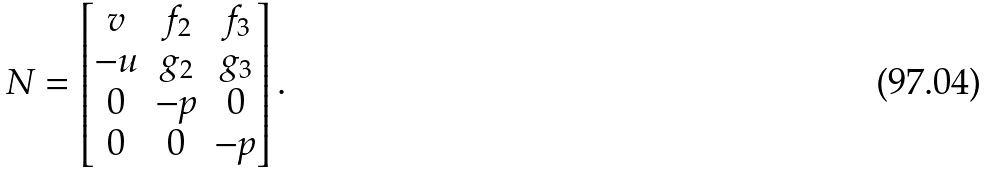<formula> <loc_0><loc_0><loc_500><loc_500>N = \left [ \begin{matrix} v & f _ { 2 } & f _ { 3 } \\ - u & g _ { 2 } & g _ { 3 } \\ 0 & - p & 0 \\ 0 & 0 & - p \end{matrix} \right ] .</formula> 